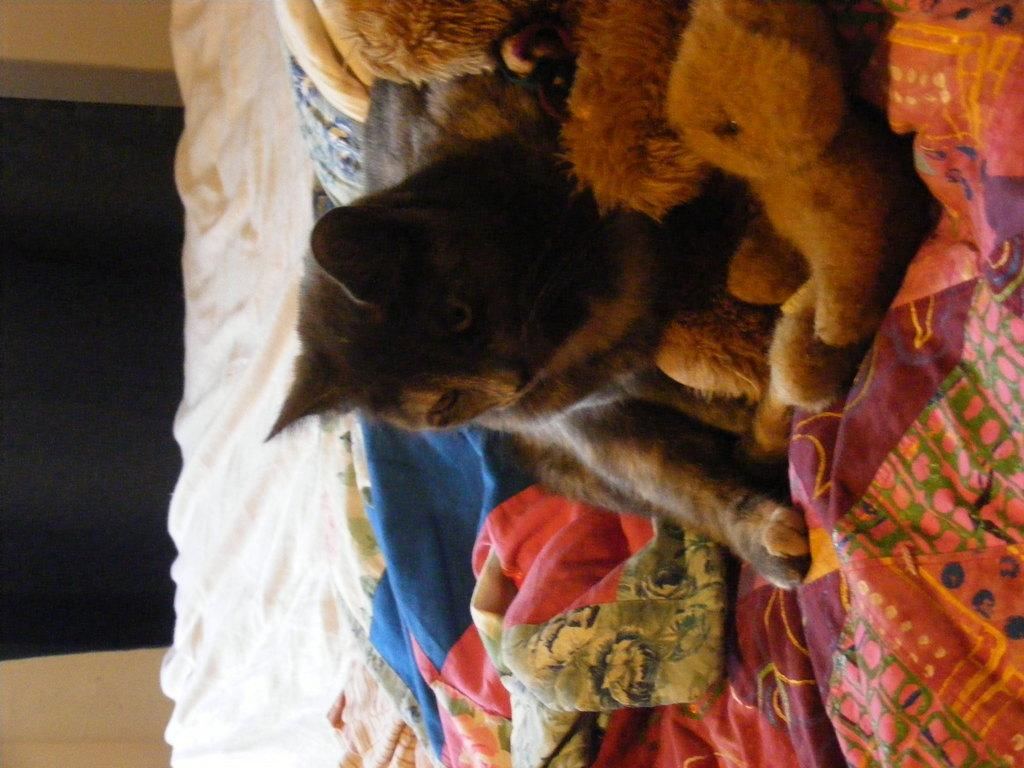What type of animal is in the image? There is an animal in the image, but the specific type cannot be determined from the provided facts. Where is the animal located in the image? The animal is on a bed in the image. What other items can be seen near the animal? There are soft toys beside the animal in the image. What is the price of the hat worn by the animal in the image? There is no hat worn by the animal in the image, and therefore no price can be determined. 